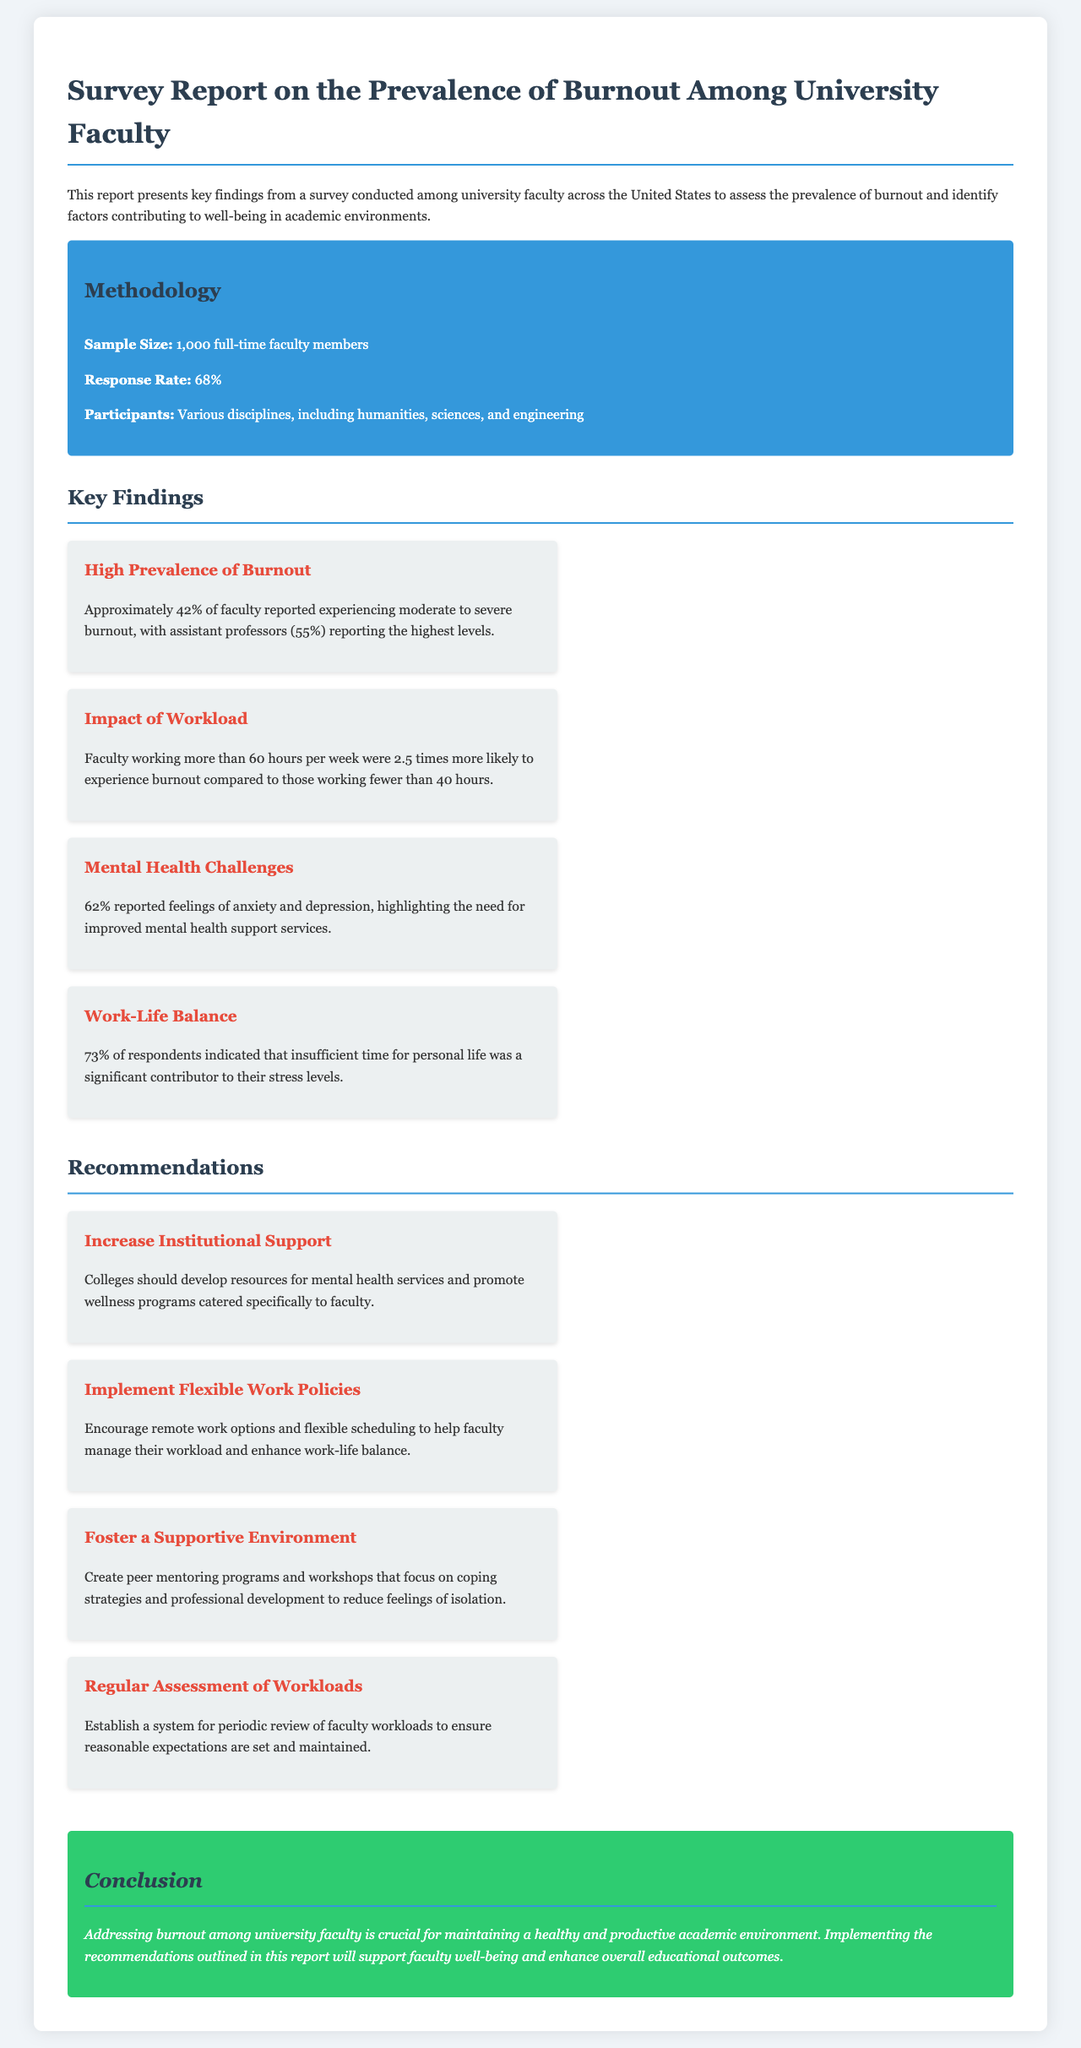What was the sample size of the survey? The sample size is mentioned in the methodology section of the document, indicating the total number of faculty who participated in the survey.
Answer: 1,000 What percentage of faculty reported experiencing moderate to severe burnout? This percentage is highlighted in the key findings, providing a clear insight into the prevalence of burnout among faculty.
Answer: 42% Which group reported the highest levels of burnout? The document specifies the group that experienced the greatest levels of burnout, which is relevant for understanding demographic differences.
Answer: Assistant professors What is the reported percentage of faculty who indicated feelings of anxiety and depression? This statistic is included in the key findings and reflects mental health challenges faced by faculty.
Answer: 62% What recommendation is made for increasing mental health support? The document lists several recommendations; one pertains specifically to strengthening resources for mental health services.
Answer: Increase Institutional Support How many times more likely are faculty working more than 60 hours a week to experience burnout? This statistic connects workload to burnout risk, providing valuable insights for policy changes.
Answer: 2.5 times What percentage of respondents indicated insufficient time for personal life as a significant contributor to stress? This finding addresses a key aspect of faculty well-being by analyzing factors contributing to stress.
Answer: 73% What strategy is suggested to help enhance work-life balance? The document provides a recommendation that directly aims to improve work-life balance among faculty.
Answer: Implement Flexible Work Policies What should be established for periodic review of faculty workloads? The recommendations section mentions a specific action to ensure reasonable workload expectations.
Answer: Regular Assessment of Workloads 